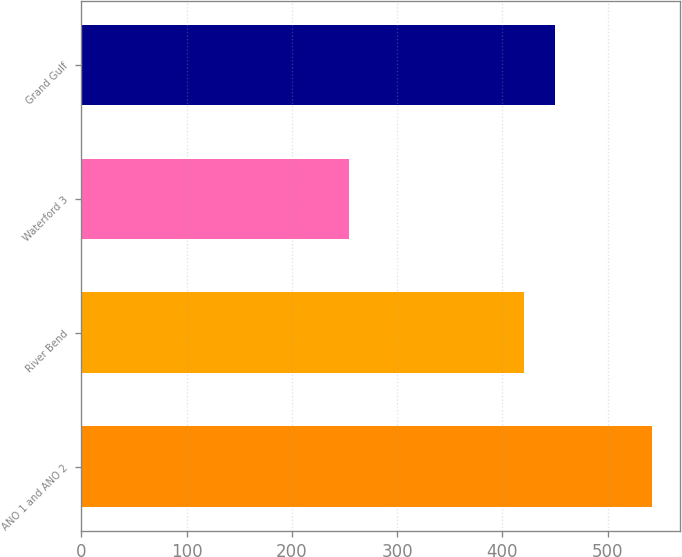Convert chart. <chart><loc_0><loc_0><loc_500><loc_500><bar_chart><fcel>ANO 1 and ANO 2<fcel>River Bend<fcel>Waterford 3<fcel>Grand Gulf<nl><fcel>541.7<fcel>420.9<fcel>254<fcel>449.67<nl></chart> 